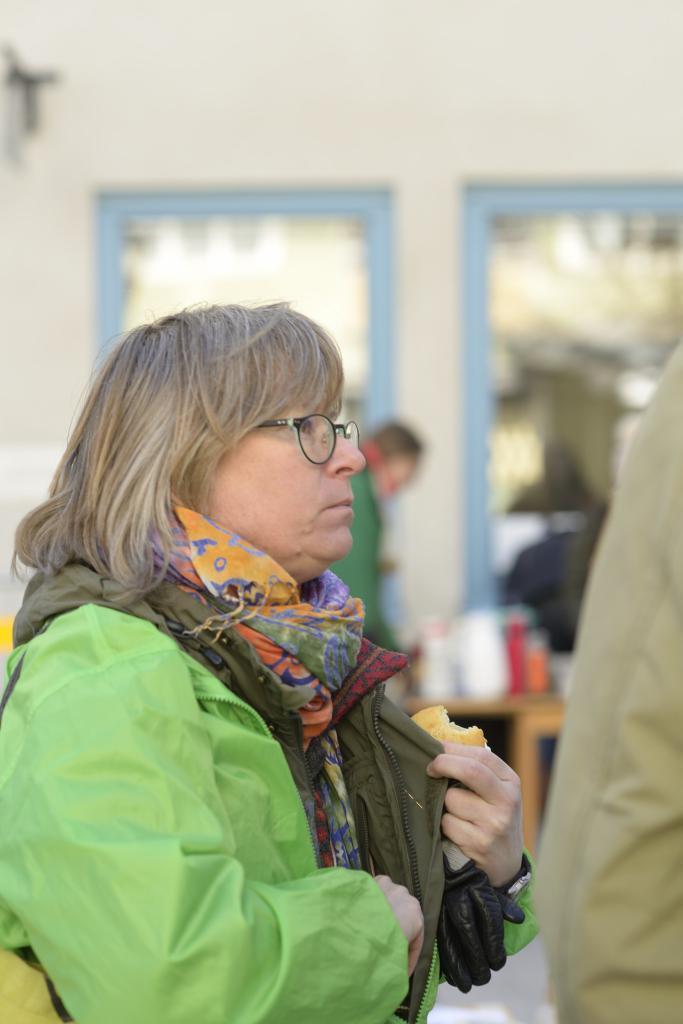Describe this image in one or two sentences. In the foreground of this image, there is a woman in green coat and wearing a bag is holding a bun in her hand. On the right, it seems like a hand of a person. In the background, there is a person's standing near a table on which there are few objects and also there is a wall. 